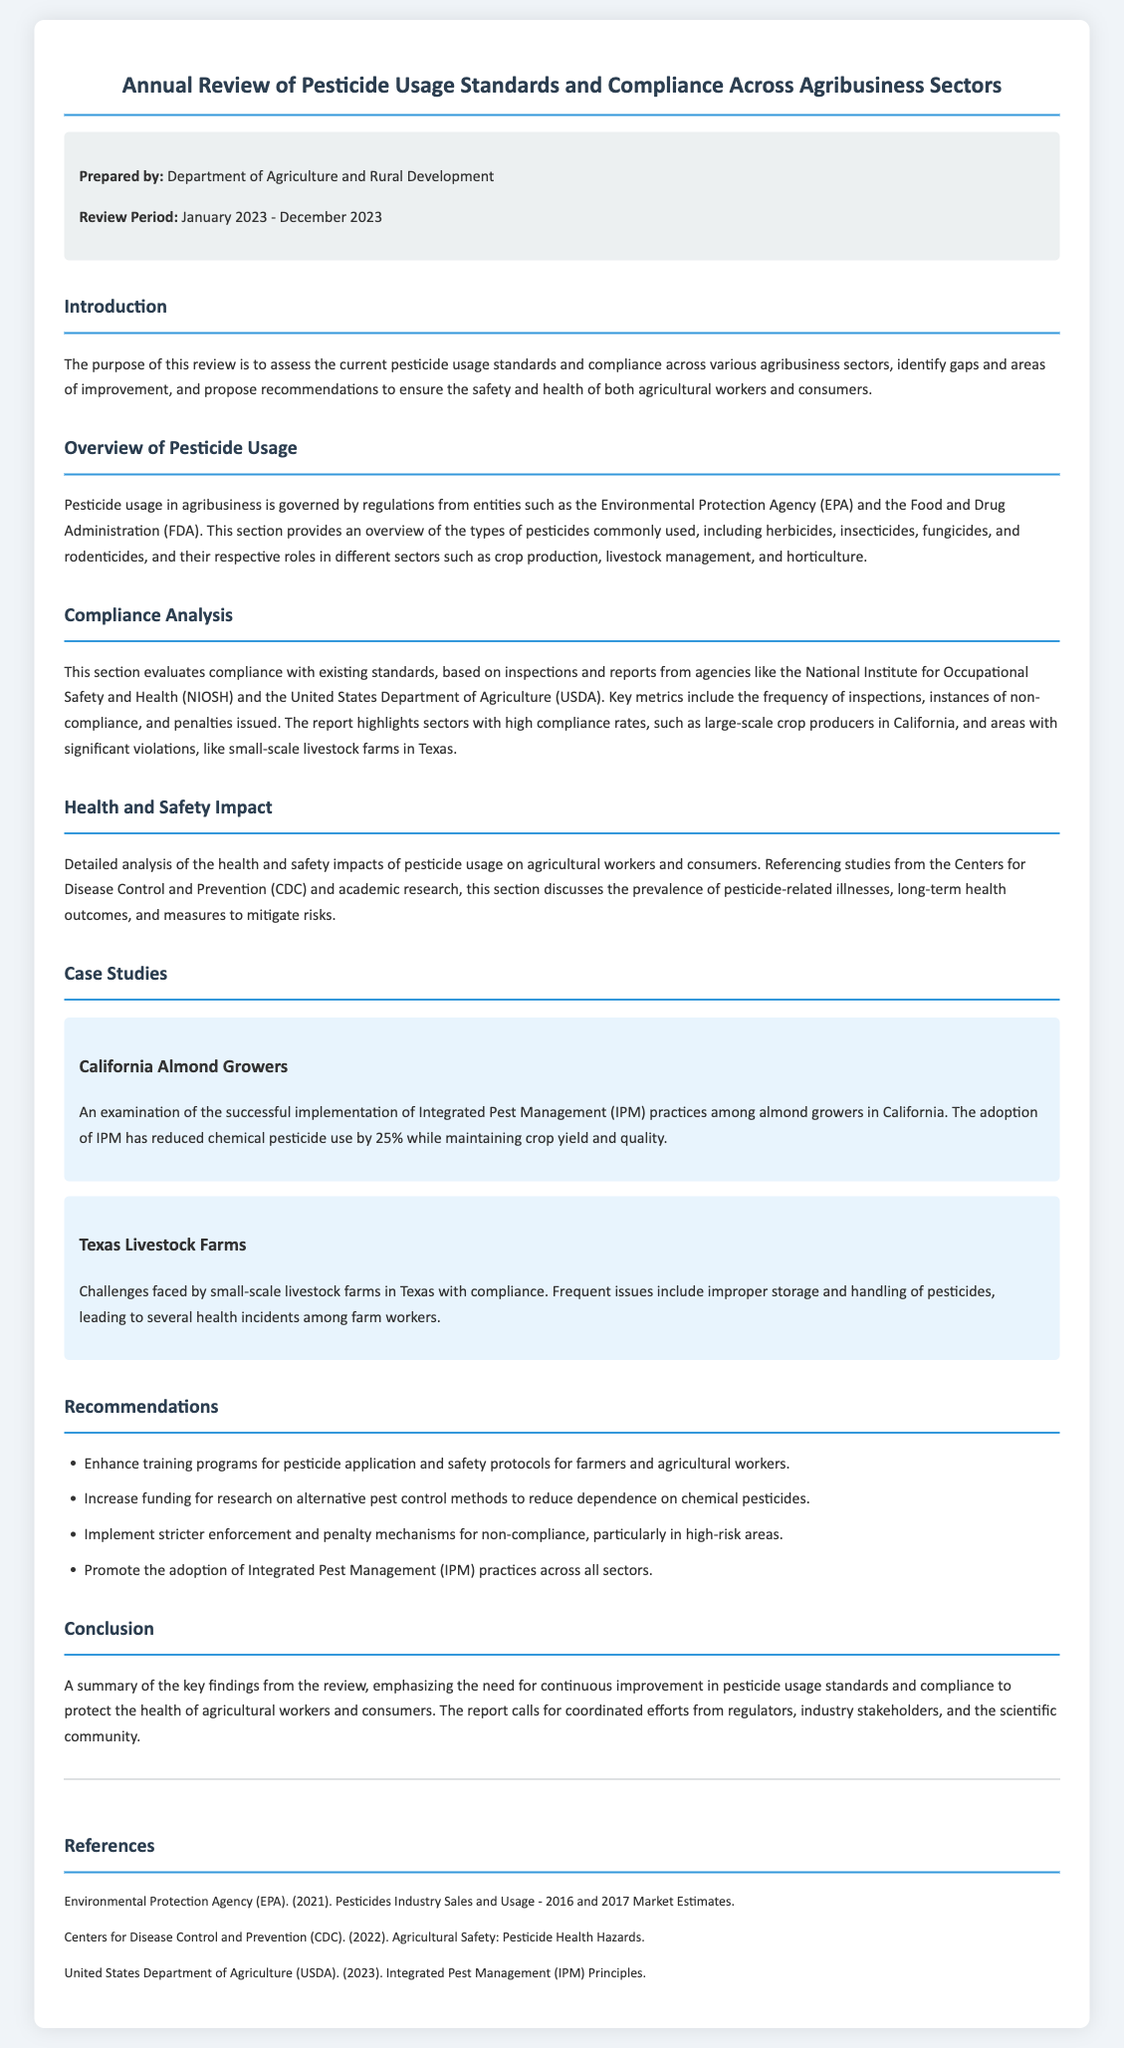what is the review period? The review period indicates the duration for which the pesticide usage standards are being evaluated, which is from January 2023 to December 2023.
Answer: January 2023 - December 2023 who prepared the document? The document is prepared by a specific department that oversees agricultural policies and standards.
Answer: Department of Agriculture and Rural Development what type of pesticides are analyzed in the document? The document lists specific categories of pesticides that are part of the review, including various types used in agribusiness.
Answer: herbicides, insecticides, fungicides, rodenticides which state's crop producers have high compliance rates? The analysis of compliance rates identifies specific regions with satisfactory adherence to pesticide usage standards.
Answer: California what is one of the main challenges faced by small-scale livestock farms in Texas? The document highlights issues related to pesticide management that these farms encounter, affecting compliance.
Answer: improper storage and handling how much has chemical pesticide use decreased among California almond growers? The document provides a statistical figure related to the reduction of pesticide usage as a result of implementing specific practices.
Answer: 25% what is one recommendation provided in the document? The document includes suggestions for improving pesticide usage standards and safety protocols in agribusiness.
Answer: Enhance training programs for pesticide application what does IPM stand for? The acronym refers to an approach mentioned in the document that integrates various pest management practices to reduce pesticide dependency.
Answer: Integrated Pest Management who conducted inspections for compliance analysis? The document attributes the evaluations of compliance with pesticide standards to regulatory and safety agencies.
Answer: National Institute for Occupational Safety and Health (NIOSH) and the United States Department of Agriculture (USDA) 